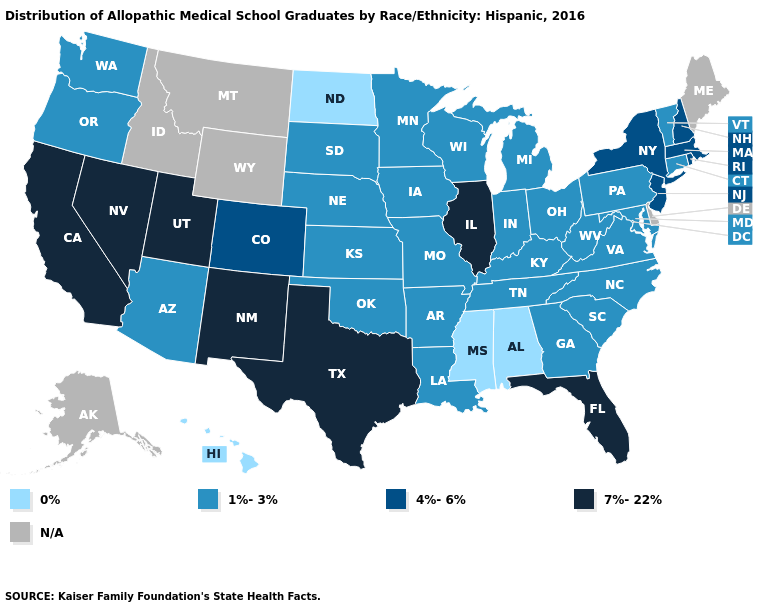What is the highest value in the MidWest ?
Write a very short answer. 7%-22%. What is the value of Virginia?
Quick response, please. 1%-3%. What is the value of Delaware?
Give a very brief answer. N/A. Is the legend a continuous bar?
Short answer required. No. Among the states that border Utah , does Nevada have the highest value?
Answer briefly. Yes. Name the states that have a value in the range 7%-22%?
Concise answer only. California, Florida, Illinois, Nevada, New Mexico, Texas, Utah. Which states have the lowest value in the West?
Be succinct. Hawaii. What is the value of North Carolina?
Give a very brief answer. 1%-3%. Does Massachusetts have the highest value in the Northeast?
Give a very brief answer. Yes. Among the states that border Mississippi , which have the lowest value?
Concise answer only. Alabama. Name the states that have a value in the range 7%-22%?
Concise answer only. California, Florida, Illinois, Nevada, New Mexico, Texas, Utah. What is the value of Missouri?
Short answer required. 1%-3%. Which states have the lowest value in the USA?
Concise answer only. Alabama, Hawaii, Mississippi, North Dakota. Which states have the highest value in the USA?
Write a very short answer. California, Florida, Illinois, Nevada, New Mexico, Texas, Utah. 